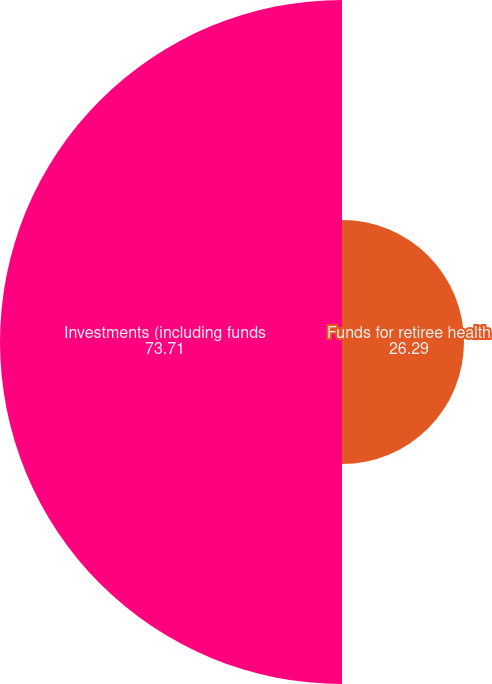Convert chart. <chart><loc_0><loc_0><loc_500><loc_500><pie_chart><fcel>Funds for retiree health<fcel>Investments (including funds<nl><fcel>26.29%<fcel>73.71%<nl></chart> 